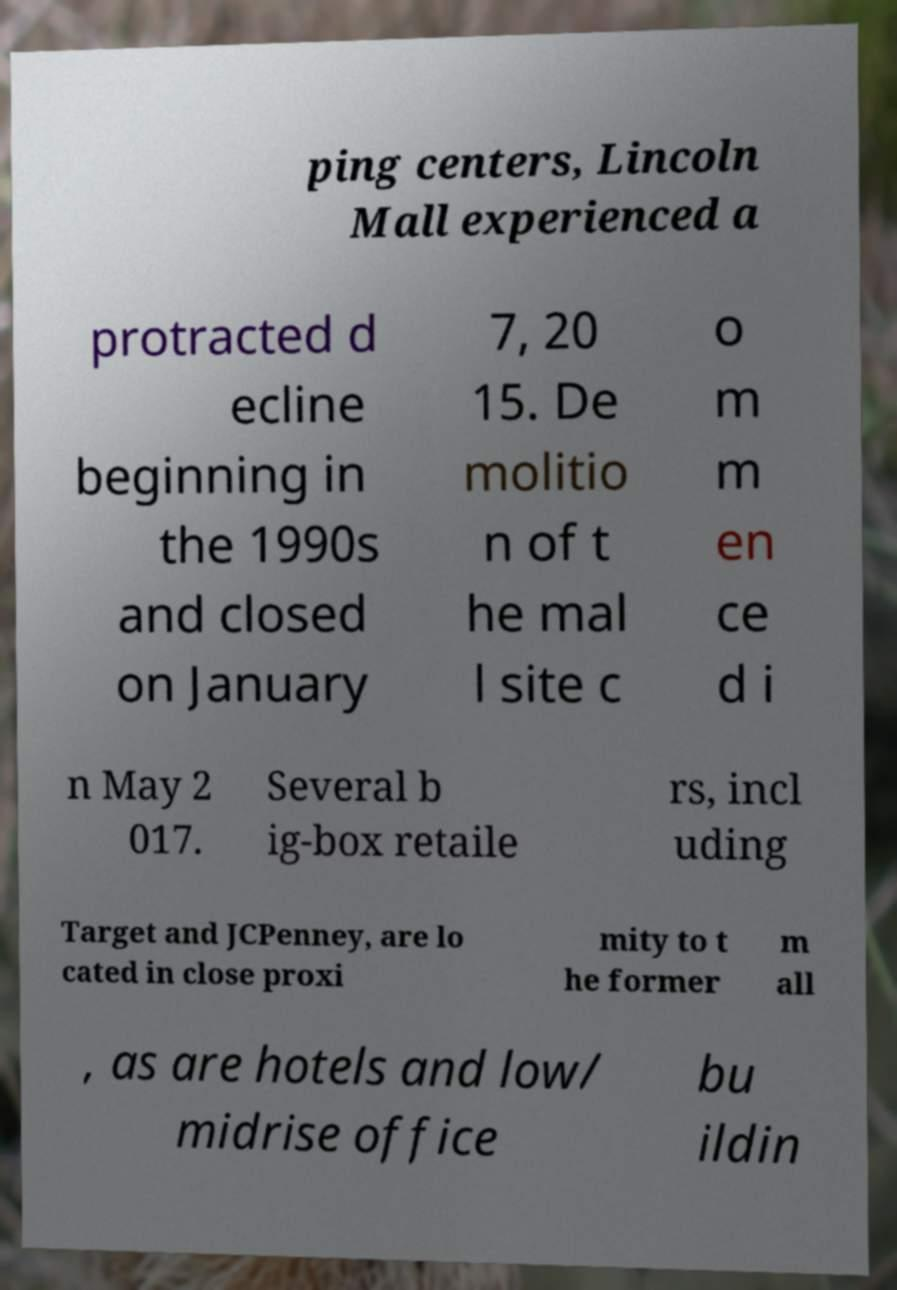Please identify and transcribe the text found in this image. ping centers, Lincoln Mall experienced a protracted d ecline beginning in the 1990s and closed on January 7, 20 15. De molitio n of t he mal l site c o m m en ce d i n May 2 017. Several b ig-box retaile rs, incl uding Target and JCPenney, are lo cated in close proxi mity to t he former m all , as are hotels and low/ midrise office bu ildin 